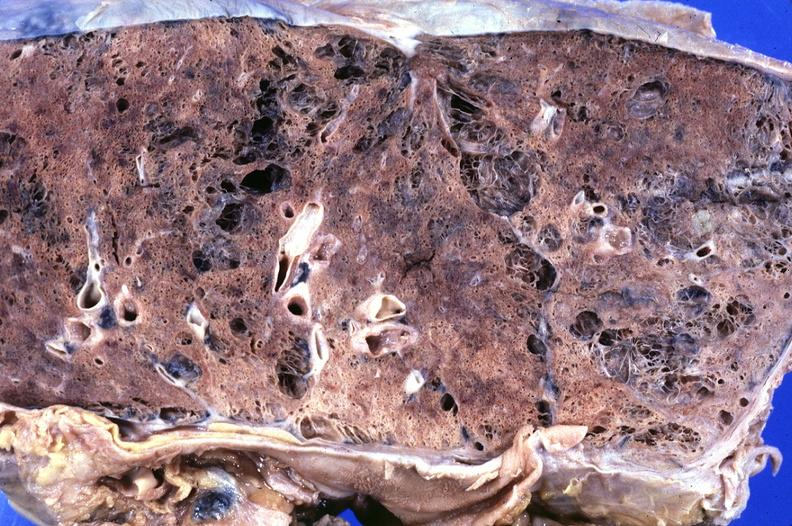where is this?
Answer the question using a single word or phrase. Lung 